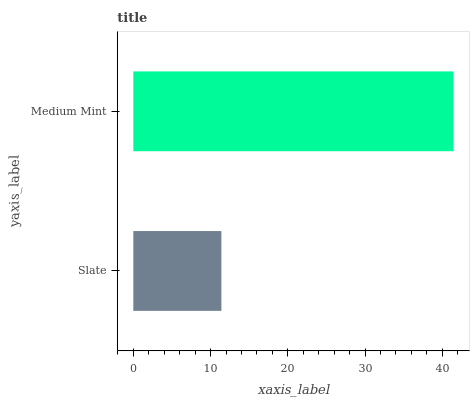Is Slate the minimum?
Answer yes or no. Yes. Is Medium Mint the maximum?
Answer yes or no. Yes. Is Medium Mint the minimum?
Answer yes or no. No. Is Medium Mint greater than Slate?
Answer yes or no. Yes. Is Slate less than Medium Mint?
Answer yes or no. Yes. Is Slate greater than Medium Mint?
Answer yes or no. No. Is Medium Mint less than Slate?
Answer yes or no. No. Is Medium Mint the high median?
Answer yes or no. Yes. Is Slate the low median?
Answer yes or no. Yes. Is Slate the high median?
Answer yes or no. No. Is Medium Mint the low median?
Answer yes or no. No. 